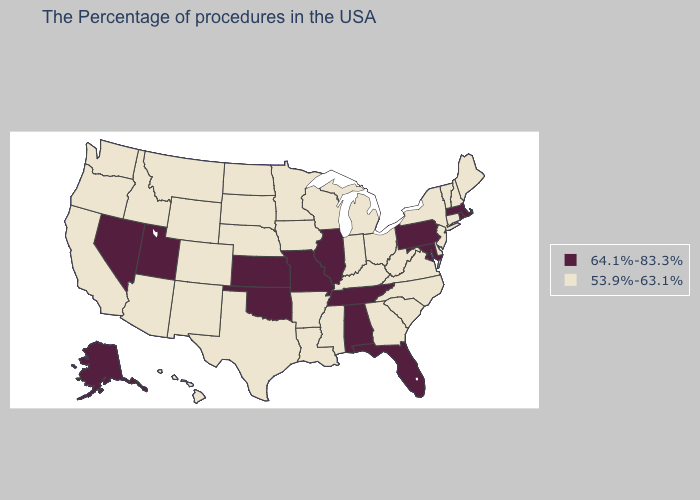What is the highest value in the South ?
Give a very brief answer. 64.1%-83.3%. Name the states that have a value in the range 53.9%-63.1%?
Keep it brief. Maine, New Hampshire, Vermont, Connecticut, New York, New Jersey, Delaware, Virginia, North Carolina, South Carolina, West Virginia, Ohio, Georgia, Michigan, Kentucky, Indiana, Wisconsin, Mississippi, Louisiana, Arkansas, Minnesota, Iowa, Nebraska, Texas, South Dakota, North Dakota, Wyoming, Colorado, New Mexico, Montana, Arizona, Idaho, California, Washington, Oregon, Hawaii. Name the states that have a value in the range 53.9%-63.1%?
Short answer required. Maine, New Hampshire, Vermont, Connecticut, New York, New Jersey, Delaware, Virginia, North Carolina, South Carolina, West Virginia, Ohio, Georgia, Michigan, Kentucky, Indiana, Wisconsin, Mississippi, Louisiana, Arkansas, Minnesota, Iowa, Nebraska, Texas, South Dakota, North Dakota, Wyoming, Colorado, New Mexico, Montana, Arizona, Idaho, California, Washington, Oregon, Hawaii. Does South Dakota have the lowest value in the USA?
Write a very short answer. Yes. Does North Dakota have a lower value than Kansas?
Give a very brief answer. Yes. Among the states that border Oregon , does Nevada have the highest value?
Give a very brief answer. Yes. Among the states that border Tennessee , does Arkansas have the lowest value?
Answer briefly. Yes. Among the states that border Alabama , which have the lowest value?
Short answer required. Georgia, Mississippi. Name the states that have a value in the range 64.1%-83.3%?
Answer briefly. Massachusetts, Rhode Island, Maryland, Pennsylvania, Florida, Alabama, Tennessee, Illinois, Missouri, Kansas, Oklahoma, Utah, Nevada, Alaska. Which states have the highest value in the USA?
Write a very short answer. Massachusetts, Rhode Island, Maryland, Pennsylvania, Florida, Alabama, Tennessee, Illinois, Missouri, Kansas, Oklahoma, Utah, Nevada, Alaska. What is the lowest value in states that border Iowa?
Write a very short answer. 53.9%-63.1%. Among the states that border Massachusetts , does Vermont have the highest value?
Concise answer only. No. What is the value of Indiana?
Write a very short answer. 53.9%-63.1%. What is the highest value in the USA?
Short answer required. 64.1%-83.3%. What is the value of Oklahoma?
Keep it brief. 64.1%-83.3%. 